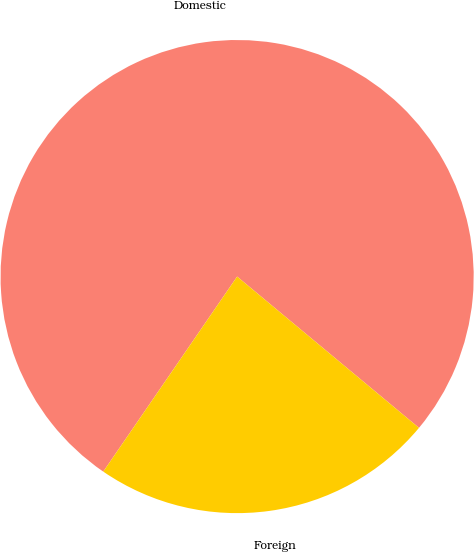<chart> <loc_0><loc_0><loc_500><loc_500><pie_chart><fcel>Domestic<fcel>Foreign<nl><fcel>76.47%<fcel>23.53%<nl></chart> 